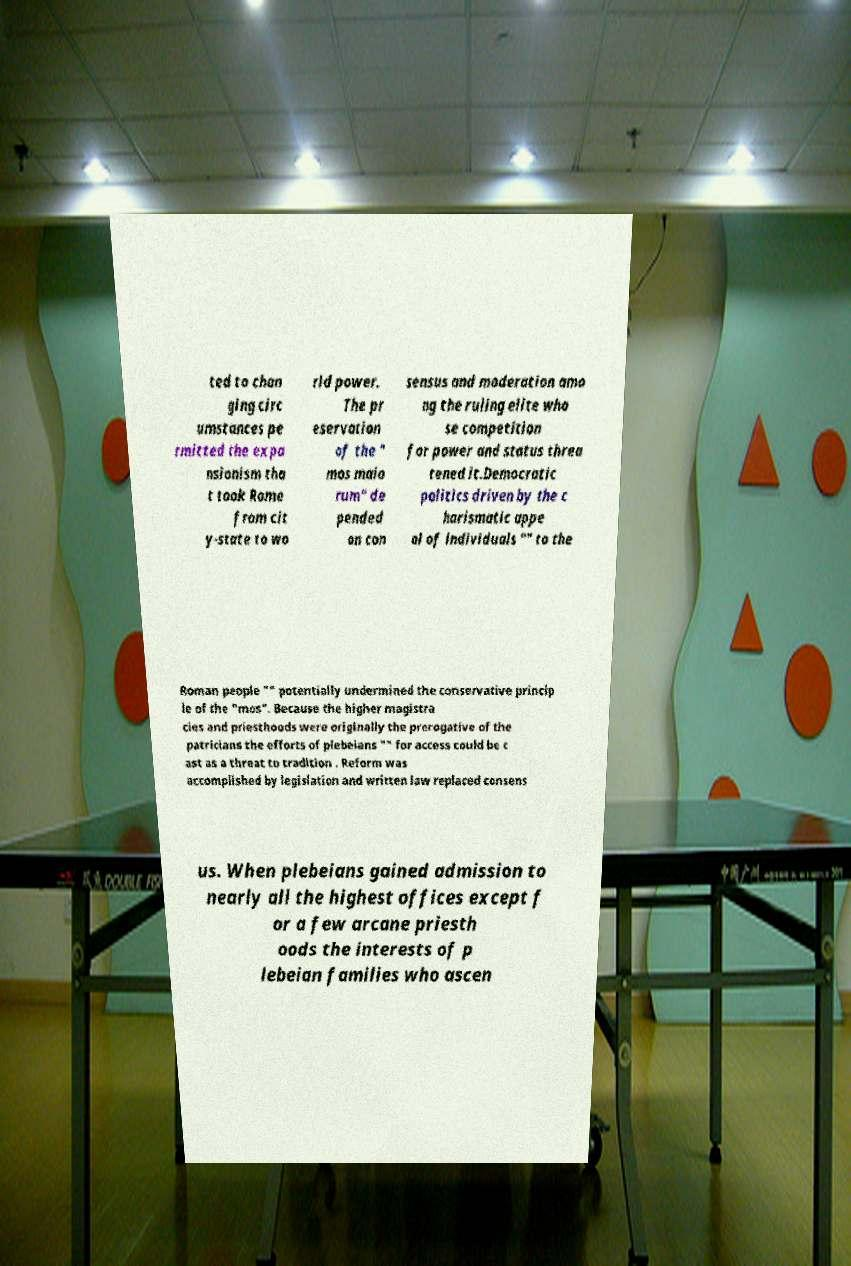What messages or text are displayed in this image? I need them in a readable, typed format. ted to chan ging circ umstances pe rmitted the expa nsionism tha t took Rome from cit y-state to wo rld power. The pr eservation of the " mos maio rum" de pended on con sensus and moderation amo ng the ruling elite who se competition for power and status threa tened it.Democratic politics driven by the c harismatic appe al of individuals "" to the Roman people "" potentially undermined the conservative princip le of the "mos". Because the higher magistra cies and priesthoods were originally the prerogative of the patricians the efforts of plebeians "" for access could be c ast as a threat to tradition . Reform was accomplished by legislation and written law replaced consens us. When plebeians gained admission to nearly all the highest offices except f or a few arcane priesth oods the interests of p lebeian families who ascen 